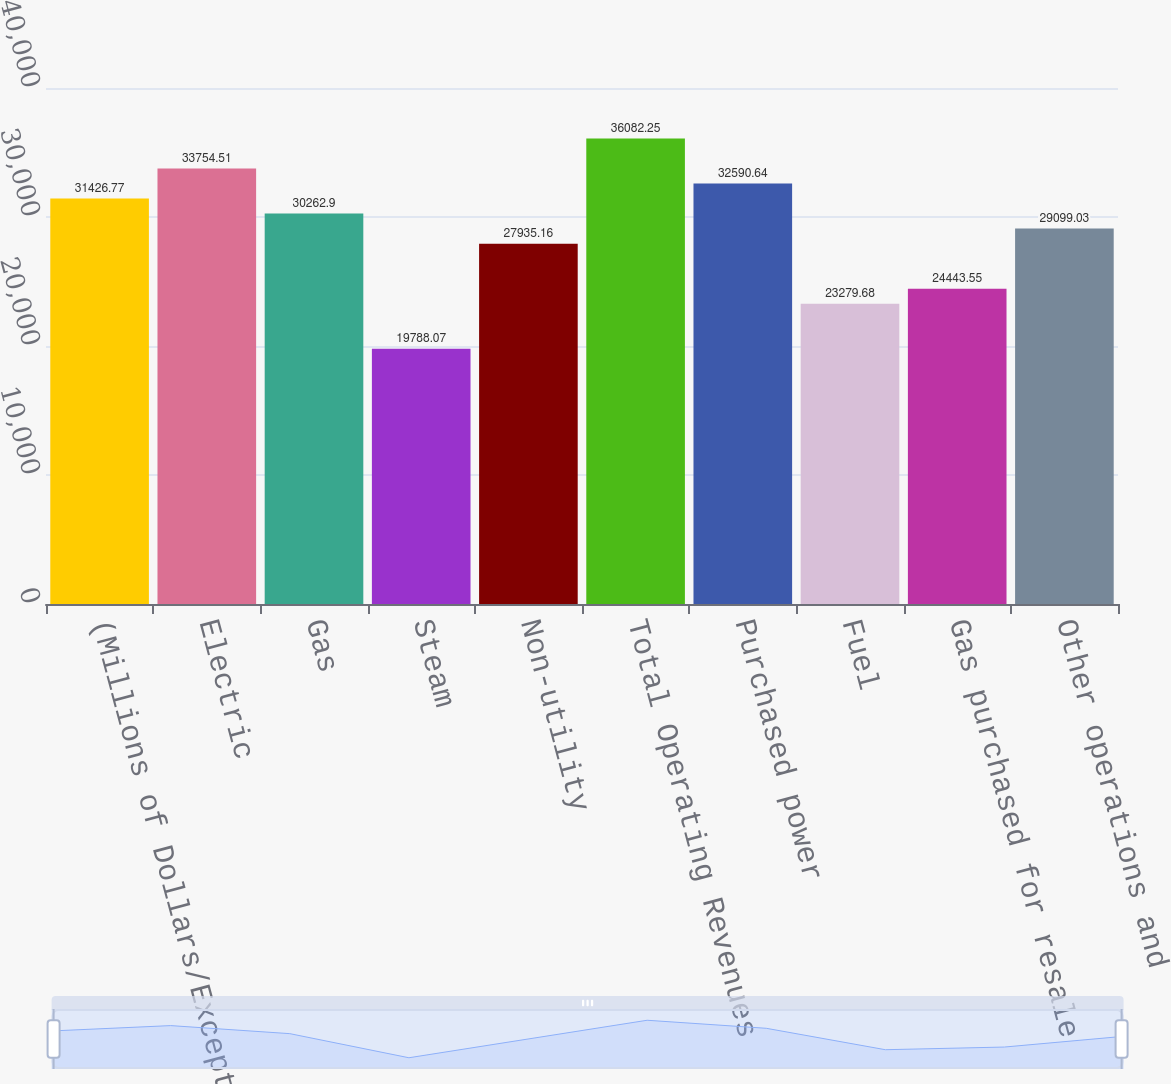Convert chart. <chart><loc_0><loc_0><loc_500><loc_500><bar_chart><fcel>(Millions of Dollars/Except<fcel>Electric<fcel>Gas<fcel>Steam<fcel>Non-utility<fcel>Total Operating Revenues<fcel>Purchased power<fcel>Fuel<fcel>Gas purchased for resale<fcel>Other operations and<nl><fcel>31426.8<fcel>33754.5<fcel>30262.9<fcel>19788.1<fcel>27935.2<fcel>36082.2<fcel>32590.6<fcel>23279.7<fcel>24443.5<fcel>29099<nl></chart> 